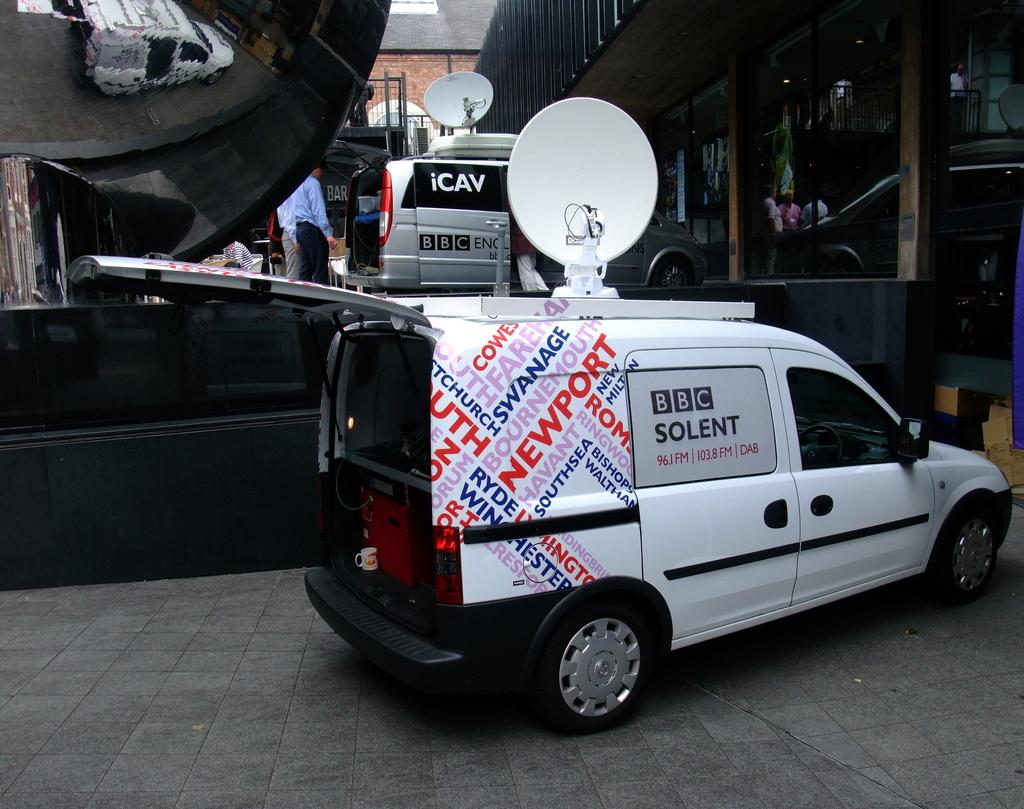What are the vehicles in the image carrying? The vehicles in the image are carrying dishes. How are the vehicles positioned in the image? The vehicles are placed on the ground. What can be seen on the building in the image? There is a building with windows in the image. Who is present near the building? Two men are standing near the building. What type of sweater is the coal wearing in the image? There is no coal or sweater present in the image. 